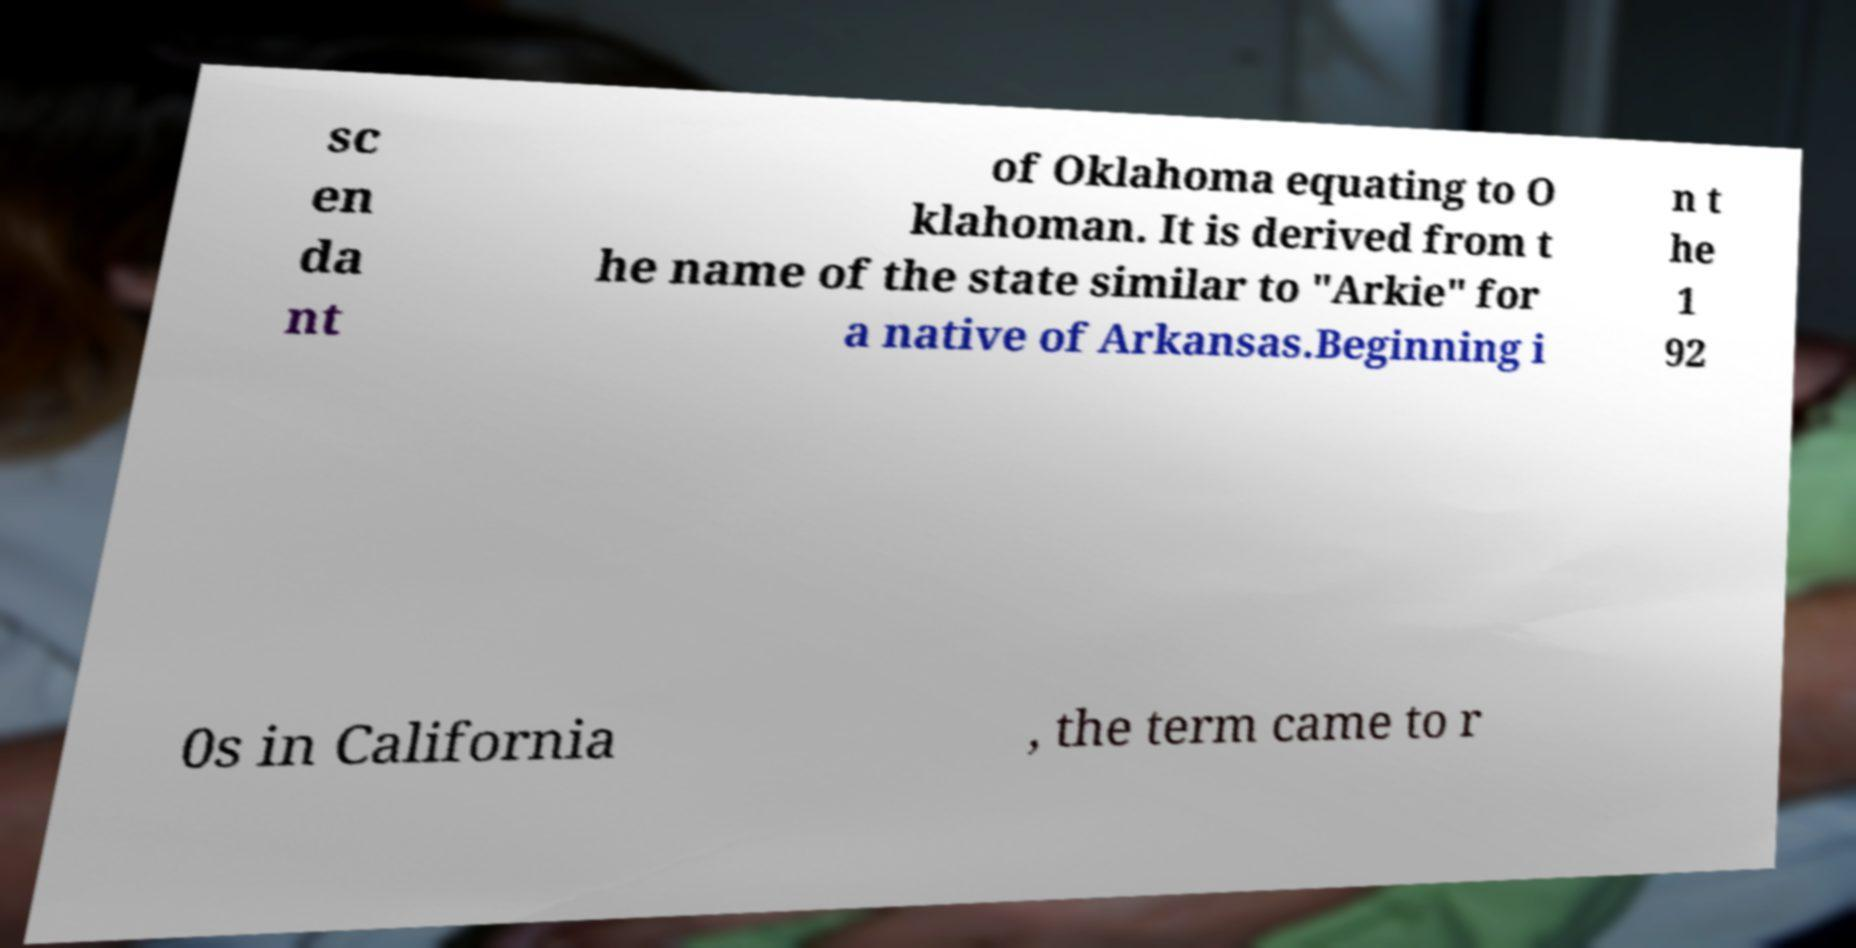What messages or text are displayed in this image? I need them in a readable, typed format. sc en da nt of Oklahoma equating to O klahoman. It is derived from t he name of the state similar to "Arkie" for a native of Arkansas.Beginning i n t he 1 92 0s in California , the term came to r 